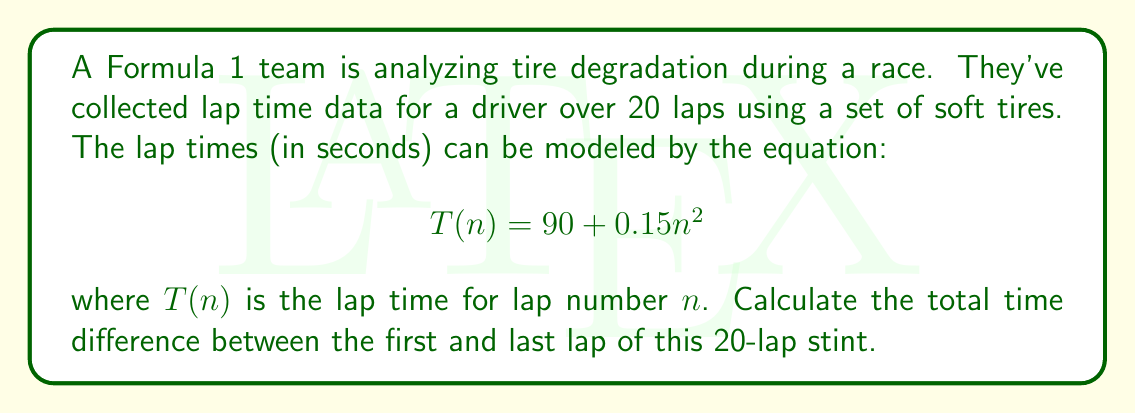Could you help me with this problem? To solve this problem, we'll follow these steps:

1. Calculate the lap time for the first lap (n = 1):
   $$T(1) = 90 + 0.15(1)^2 = 90.15 \text{ seconds}$$

2. Calculate the lap time for the last lap (n = 20):
   $$T(20) = 90 + 0.15(20)^2 = 90 + 0.15(400) = 150 \text{ seconds}$$

3. Calculate the difference between the last and first lap times:
   $$\text{Difference} = T(20) - T(1) = 150 - 90.15 = 59.85 \text{ seconds}$$

This result shows how tire degradation affects lap times over the course of a 20-lap stint. The quadratic nature of the equation reflects the increasing rate of tire wear, which is typical in motorsports. As a motorsport enthusiast, you might recognize that this significant time difference (nearly a minute) would have a major impact on race strategy, potentially necessitating a pit stop for fresh tires.
Answer: 59.85 seconds 